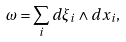Convert formula to latex. <formula><loc_0><loc_0><loc_500><loc_500>\omega = \sum _ { i } d \xi _ { i } \wedge d x _ { i } ,</formula> 